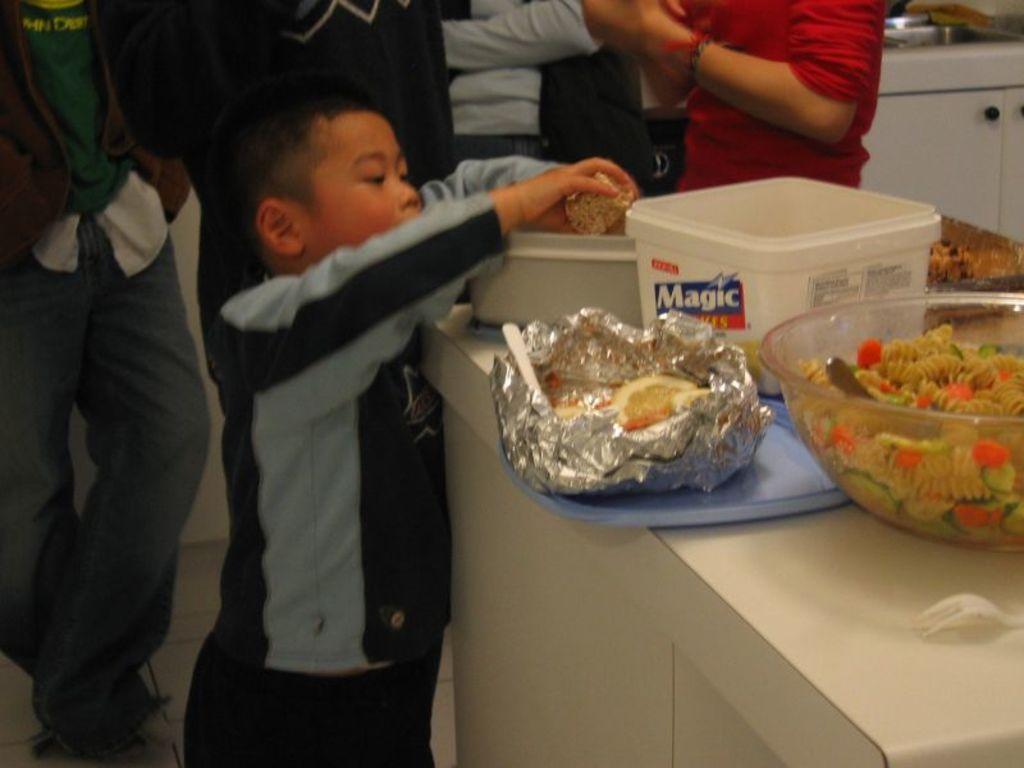Can you describe this image briefly? In the image few people are standing. Bottom right side of the image there is a table, on the table there are some bowls and spoons and food. 